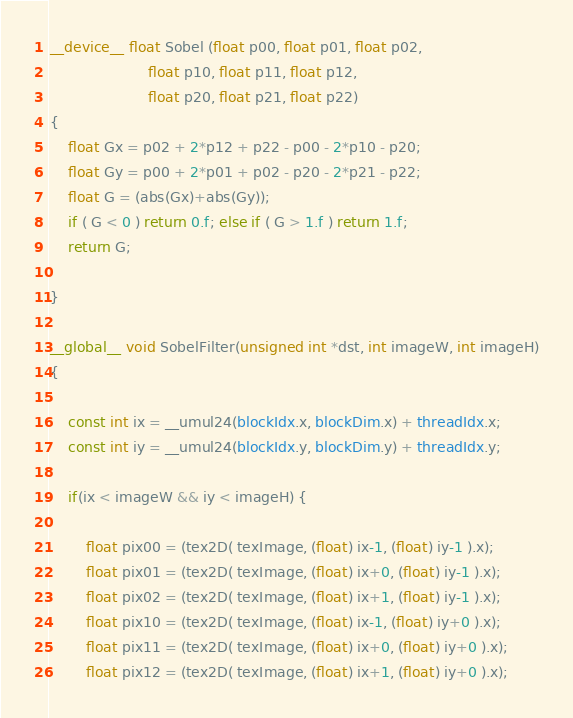Convert code to text. <code><loc_0><loc_0><loc_500><loc_500><_Cuda_>__device__ float Sobel (float p00, float p01, float p02, 
					  float p10, float p11, float p12, 
					  float p20, float p21, float p22) 
{
	float Gx = p02 + 2*p12 + p22 - p00 - 2*p10 - p20;
    float Gy = p00 + 2*p01 + p02 - p20 - 2*p21 - p22;
    float G = (abs(Gx)+abs(Gy));
    if ( G < 0 ) return 0.f; else if ( G > 1.f ) return 1.f;
    return G;

}

__global__ void SobelFilter(unsigned int *dst, int imageW, int imageH)
{	
	
    const int ix = __umul24(blockIdx.x, blockDim.x) + threadIdx.x;
    const int iy = __umul24(blockIdx.y, blockDim.y) + threadIdx.y;

	if(ix < imageW && iy < imageH) {

		float pix00 = (tex2D( texImage, (float) ix-1, (float) iy-1 ).x);
		float pix01 = (tex2D( texImage, (float) ix+0, (float) iy-1 ).x);
		float pix02 = (tex2D( texImage, (float) ix+1, (float) iy-1 ).x);
		float pix10 = (tex2D( texImage, (float) ix-1, (float) iy+0 ).x);
		float pix11 = (tex2D( texImage, (float) ix+0, (float) iy+0 ).x);
		float pix12 = (tex2D( texImage, (float) ix+1, (float) iy+0 ).x);</code> 